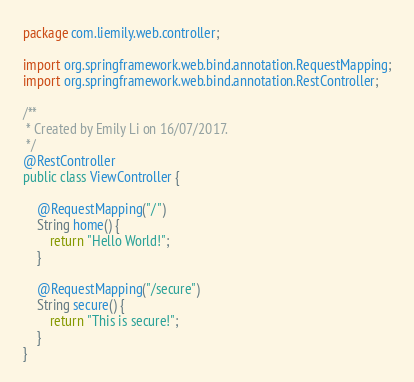<code> <loc_0><loc_0><loc_500><loc_500><_Java_>package com.liemily.web.controller;

import org.springframework.web.bind.annotation.RequestMapping;
import org.springframework.web.bind.annotation.RestController;

/**
 * Created by Emily Li on 16/07/2017.
 */
@RestController
public class ViewController {

    @RequestMapping("/")
    String home() {
        return "Hello World!";
    }

    @RequestMapping("/secure")
    String secure() {
        return "This is secure!";
    }
}
</code> 